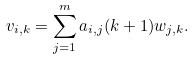Convert formula to latex. <formula><loc_0><loc_0><loc_500><loc_500>v _ { i , k } = \sum _ { j = 1 } ^ { m } a _ { i , j } ( k + 1 ) w _ { j , k } .</formula> 